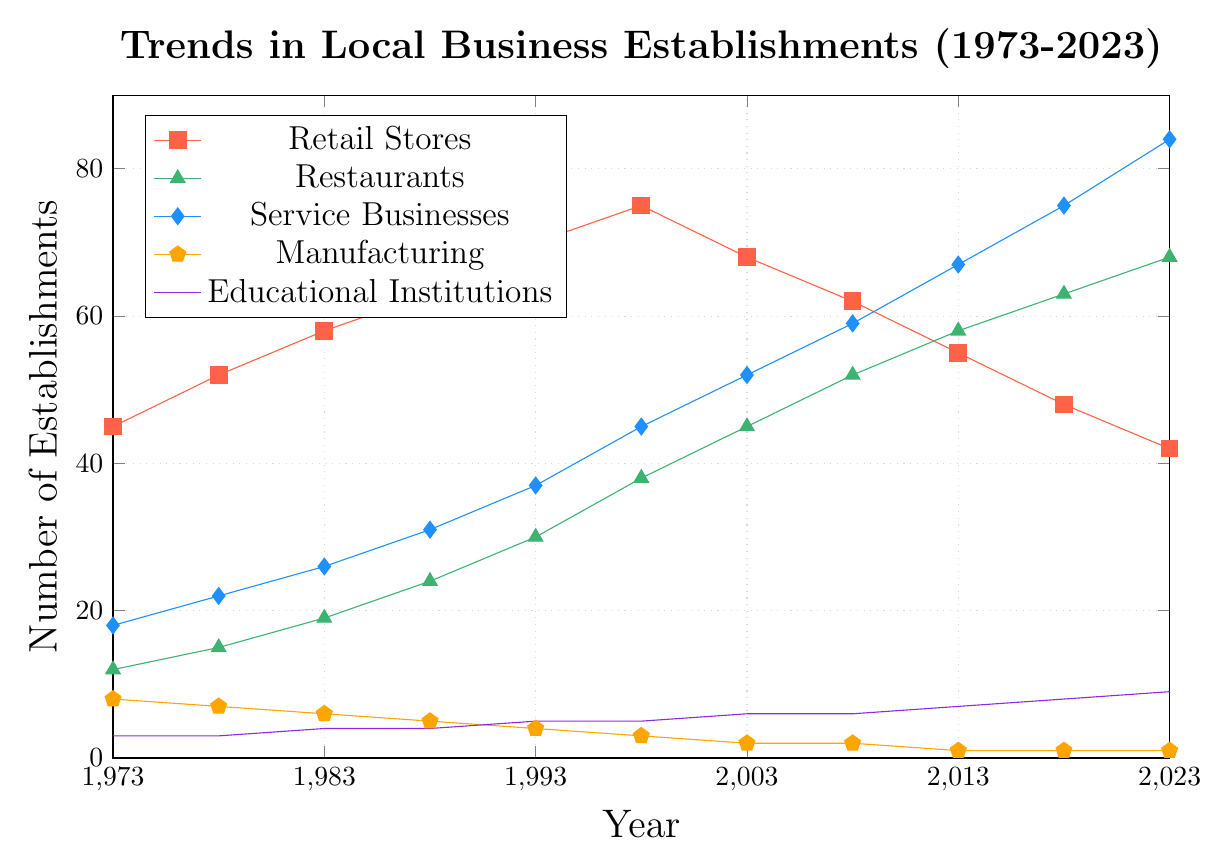How many years did it take for the number of Restaurants to increase from 12 to 30? The number of Restaurants was 12 in 1973 and 30 in 1993. Calculate the difference in years between 1973 and 1993 to find the duration.
Answer: 20 Which industry had the highest number of establishments in 2023? Identify the highest value in the year 2023 for all industry types in the figure. Service Businesses have the largest number at 84.
Answer: Service Businesses How many more Retail Stores were there in 1988 compared to Manufacturing establishments in the same year? In 1988, Retail Stores had 63 establishments and Manufacturing had 5. The difference is 63 - 5.
Answer: 58 What trend can be observed for the Manufacturing industry from 1973 to 2023? Observe the Line plot for Manufacturing from 1973 to 2023. It shows a consistent decline from 8 establishments in 1973 to 1 in 2023.
Answer: Declining What is the average number of Educational Institutions from 2003 to 2023? Count the values for Educational Institutions from 2003 (6), 2008 (6), 2013 (7), 2018 (8), and 2023 (9). Sum them up and divide by 5 to find the average: (6+6+7+8+9)/5 = 36/5.
Answer: 7.2 In which year did Service Businesses surpass Retail Stores in number? Compare the values year by year to find when Service Businesses' number first exceeds Retail Stores. This happened first in 2003 (52 Service vs. 68 Retail).
Answer: 2008 Between 1973 and 1993, which industry showed the largest absolute increase in the number of establishments? Calculate the increase for each industry between 1973 and 1993 by subtracting 1973 values from 1993. Retail Stores: 70-45=25, Restaurants: 30-12=18, Service Businesses: 37-18=19, Manufacturing: 4-8=-4, Educational Institutions: 5-3=2.
Answer: Retail Stores In which years did Educational Institutions double the number of establishments compared to 1973? Identify the number of Educational Institutions in 1973 (3) and find years where this amount doubled (6). This happened in 2003 and beyond.
Answer: 2003 By how much did the number of Restaurants change between 1998 and 2023? Note the number of Restaurants in 1998 (38) and in 2023 (68). The change is calculated as 68 - 38.
Answer: 30 What is the visual color used for indicating Service Businesses on the plot? Identify the color represented for Service Businesses based on the legend. The plot indicates Service Businesses in the blue color.
Answer: Blue 